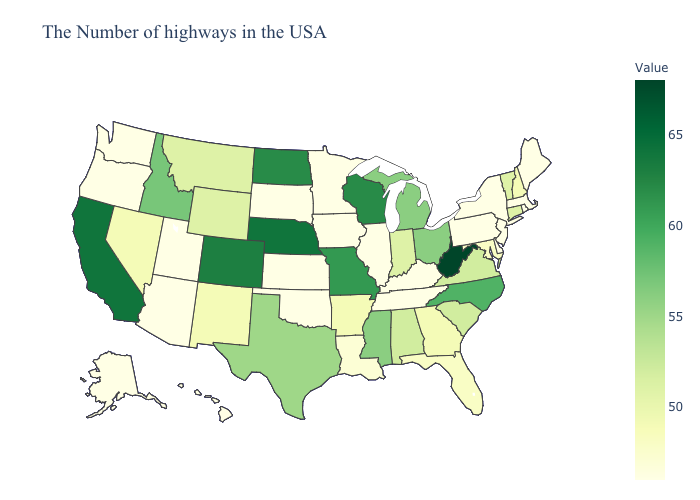Does Massachusetts have the lowest value in the USA?
Answer briefly. Yes. Does Pennsylvania have the lowest value in the USA?
Keep it brief. Yes. Does Kansas have the highest value in the MidWest?
Write a very short answer. No. Which states hav the highest value in the South?
Give a very brief answer. West Virginia. Does Virginia have a lower value than Illinois?
Give a very brief answer. No. Among the states that border West Virginia , which have the lowest value?
Quick response, please. Pennsylvania, Kentucky. Which states have the lowest value in the USA?
Answer briefly. Maine, Massachusetts, Rhode Island, New York, New Jersey, Delaware, Pennsylvania, Kentucky, Tennessee, Illinois, Minnesota, Iowa, Kansas, Oklahoma, South Dakota, Utah, Arizona, Washington, Oregon, Alaska, Hawaii. 